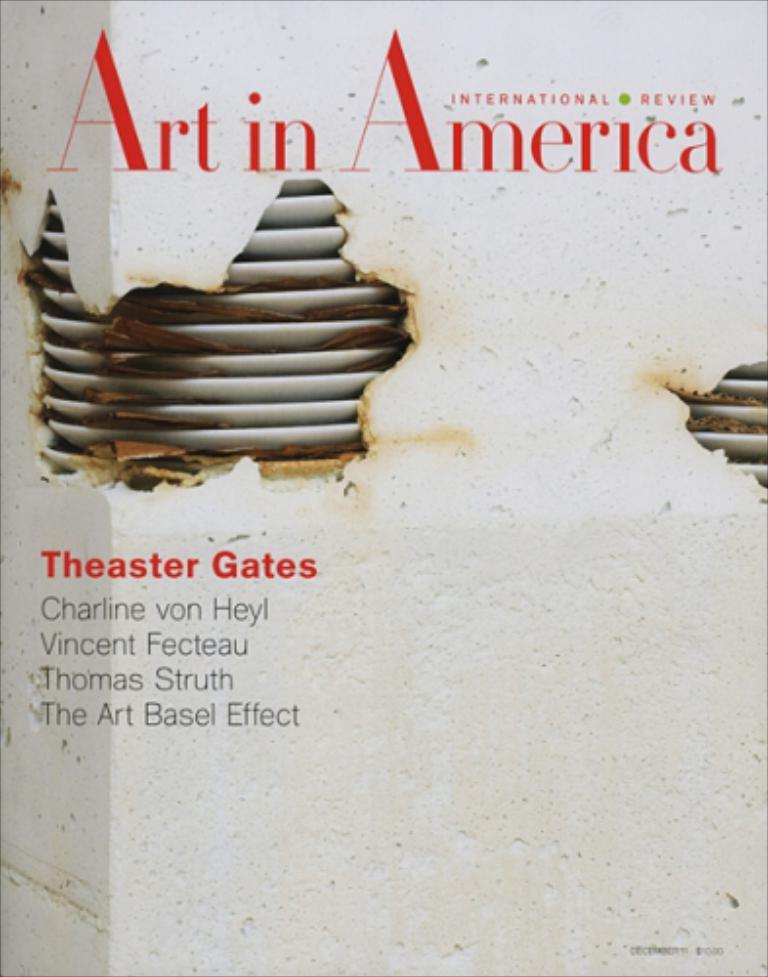<image>
Offer a succinct explanation of the picture presented. A white book titled International review: Art in America. 